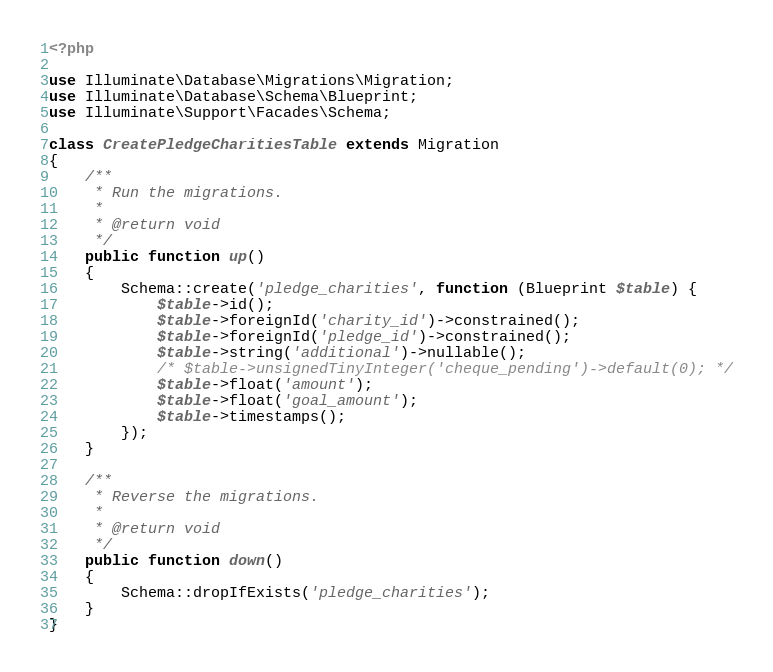<code> <loc_0><loc_0><loc_500><loc_500><_PHP_><?php

use Illuminate\Database\Migrations\Migration;
use Illuminate\Database\Schema\Blueprint;
use Illuminate\Support\Facades\Schema;

class CreatePledgeCharitiesTable extends Migration
{
    /**
     * Run the migrations.
     *
     * @return void
     */
    public function up()
    {
        Schema::create('pledge_charities', function (Blueprint $table) {
            $table->id();
            $table->foreignId('charity_id')->constrained();
            $table->foreignId('pledge_id')->constrained();
            $table->string('additional')->nullable();
            /* $table->unsignedTinyInteger('cheque_pending')->default(0); */
            $table->float('amount');
            $table->float('goal_amount');
            $table->timestamps();
        });
    }

    /**
     * Reverse the migrations.
     *
     * @return void
     */
    public function down()
    {
        Schema::dropIfExists('pledge_charities');
    }
}
</code> 